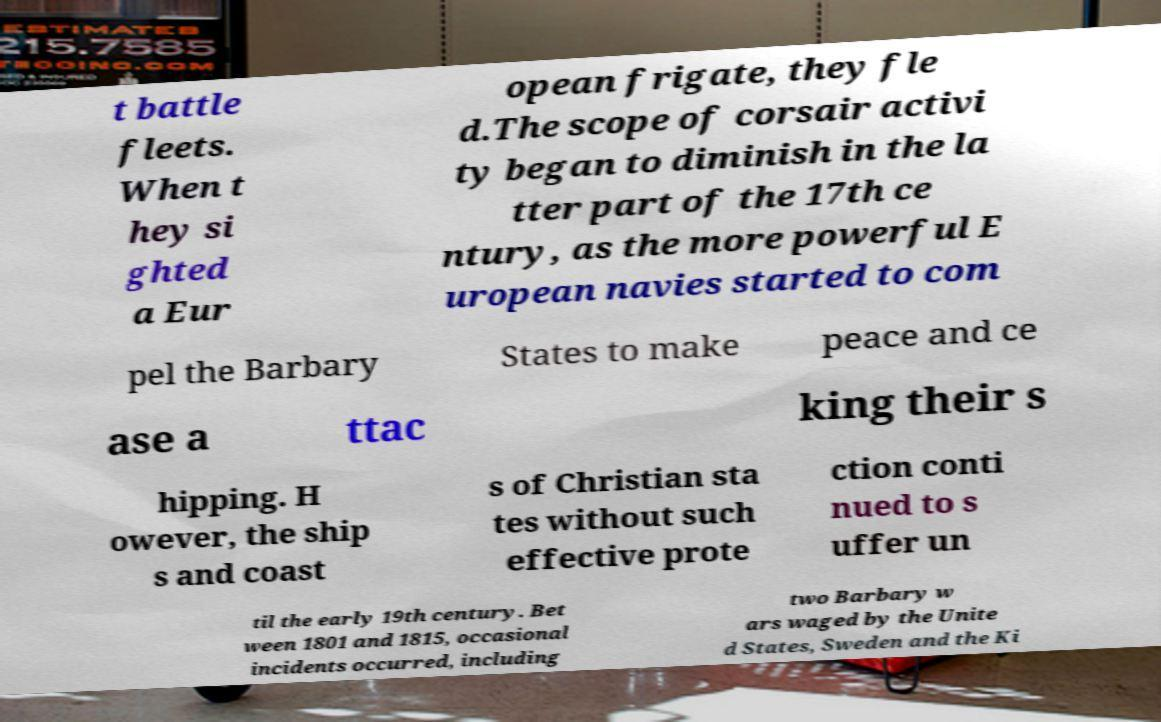Please identify and transcribe the text found in this image. t battle fleets. When t hey si ghted a Eur opean frigate, they fle d.The scope of corsair activi ty began to diminish in the la tter part of the 17th ce ntury, as the more powerful E uropean navies started to com pel the Barbary States to make peace and ce ase a ttac king their s hipping. H owever, the ship s and coast s of Christian sta tes without such effective prote ction conti nued to s uffer un til the early 19th century. Bet ween 1801 and 1815, occasional incidents occurred, including two Barbary w ars waged by the Unite d States, Sweden and the Ki 